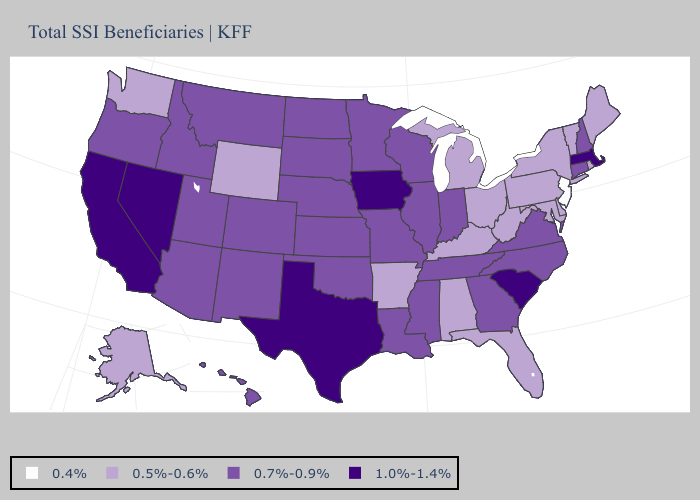Name the states that have a value in the range 0.5%-0.6%?
Short answer required. Alabama, Alaska, Arkansas, Delaware, Florida, Kentucky, Maine, Maryland, Michigan, New York, Ohio, Pennsylvania, Rhode Island, Vermont, Washington, West Virginia, Wyoming. What is the lowest value in the USA?
Give a very brief answer. 0.4%. Which states hav the highest value in the Northeast?
Be succinct. Massachusetts. What is the value of Florida?
Give a very brief answer. 0.5%-0.6%. What is the lowest value in the USA?
Keep it brief. 0.4%. Name the states that have a value in the range 1.0%-1.4%?
Be succinct. California, Iowa, Massachusetts, Nevada, South Carolina, Texas. What is the value of North Dakota?
Write a very short answer. 0.7%-0.9%. Does Michigan have a higher value than Kansas?
Write a very short answer. No. Does Idaho have the lowest value in the USA?
Write a very short answer. No. Name the states that have a value in the range 0.7%-0.9%?
Keep it brief. Arizona, Colorado, Connecticut, Georgia, Hawaii, Idaho, Illinois, Indiana, Kansas, Louisiana, Minnesota, Mississippi, Missouri, Montana, Nebraska, New Hampshire, New Mexico, North Carolina, North Dakota, Oklahoma, Oregon, South Dakota, Tennessee, Utah, Virginia, Wisconsin. What is the lowest value in the USA?
Keep it brief. 0.4%. What is the value of Nebraska?
Give a very brief answer. 0.7%-0.9%. Name the states that have a value in the range 1.0%-1.4%?
Keep it brief. California, Iowa, Massachusetts, Nevada, South Carolina, Texas. Name the states that have a value in the range 1.0%-1.4%?
Quick response, please. California, Iowa, Massachusetts, Nevada, South Carolina, Texas. Name the states that have a value in the range 1.0%-1.4%?
Be succinct. California, Iowa, Massachusetts, Nevada, South Carolina, Texas. 